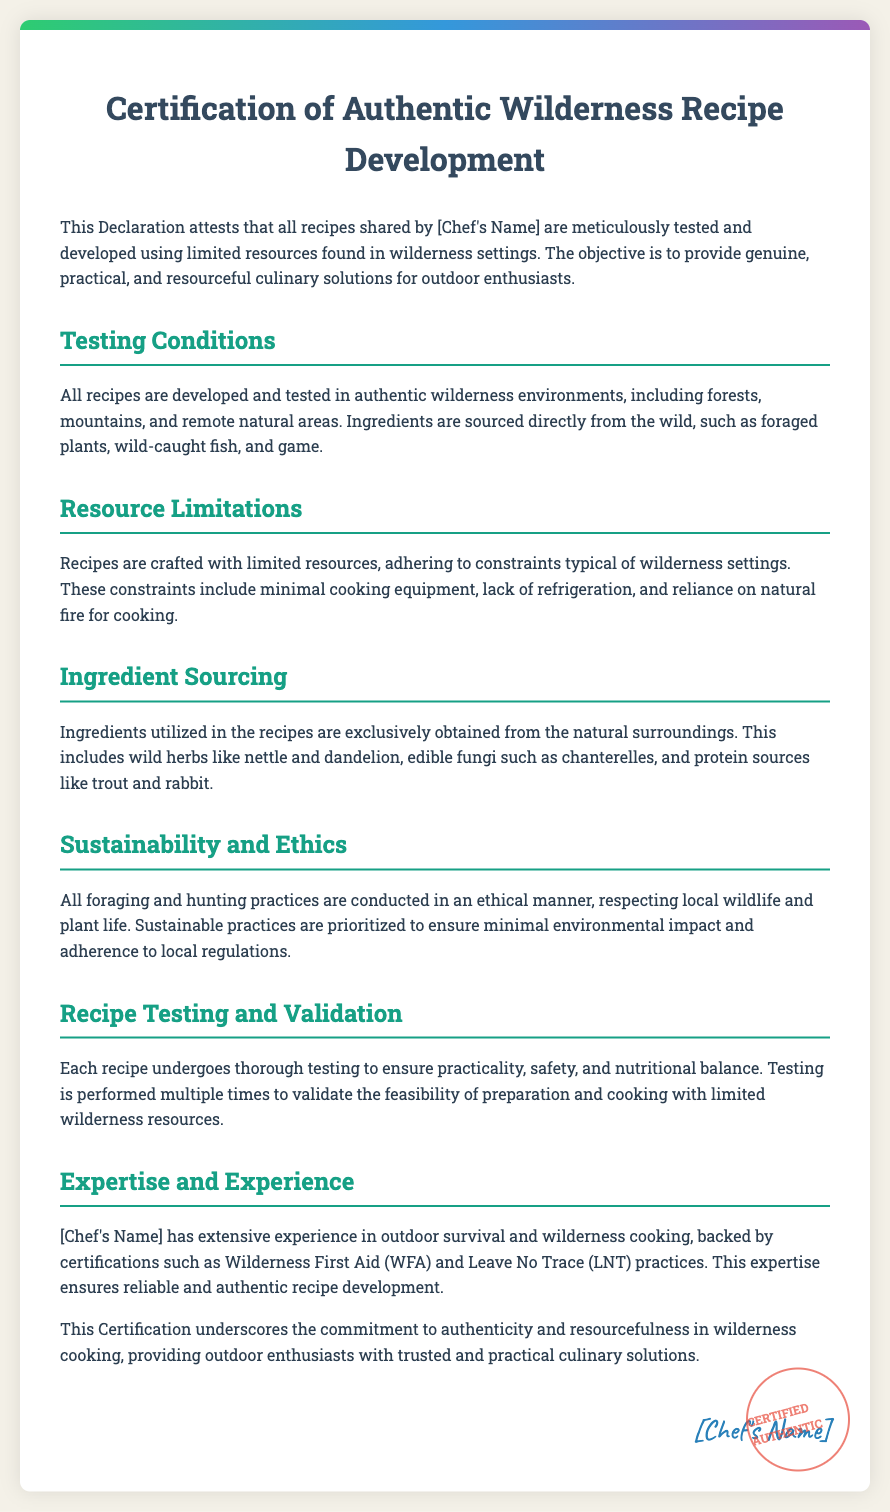what is the title of the document? The title is presented prominently at the top of the document.
Answer: Certification of Authentic Wilderness Recipe Development who is the chef behind the recipes? The chef's name is mentioned in multiple sections of the document but is a placeholder in the provided content.
Answer: [Chef's Name] what type of environments are recipes developed in? The document specifies the settings where recipes are tested and developed.
Answer: wilderness environments what is one source of ingredients mentioned? The document lists examples of ingredient sources that can be found in wilderness settings.
Answer: wild herbs what certification does the chef have? The document briefly mentions qualifications related to the chef's expertise in wilderness cooking.
Answer: Wilderness First Aid how are ethical practices related to ingredient sourcing? The document states the importance of respecting local wildlife and plant life during foraging and hunting practices.
Answer: Sustainable practices how many times is each recipe tested? The document mentions the thorough testing process described for recipe validation.
Answer: multiple times what type of cooking equipment is referred to in the document? The document specifies the limitations regarding cooking equipment available in wilderness settings.
Answer: minimal cooking equipment what does the stamp at the bottom signify? The stamp conveys a specific message about the authenticity of the recipes presented.
Answer: CERTIFIED AUTHENTIC 